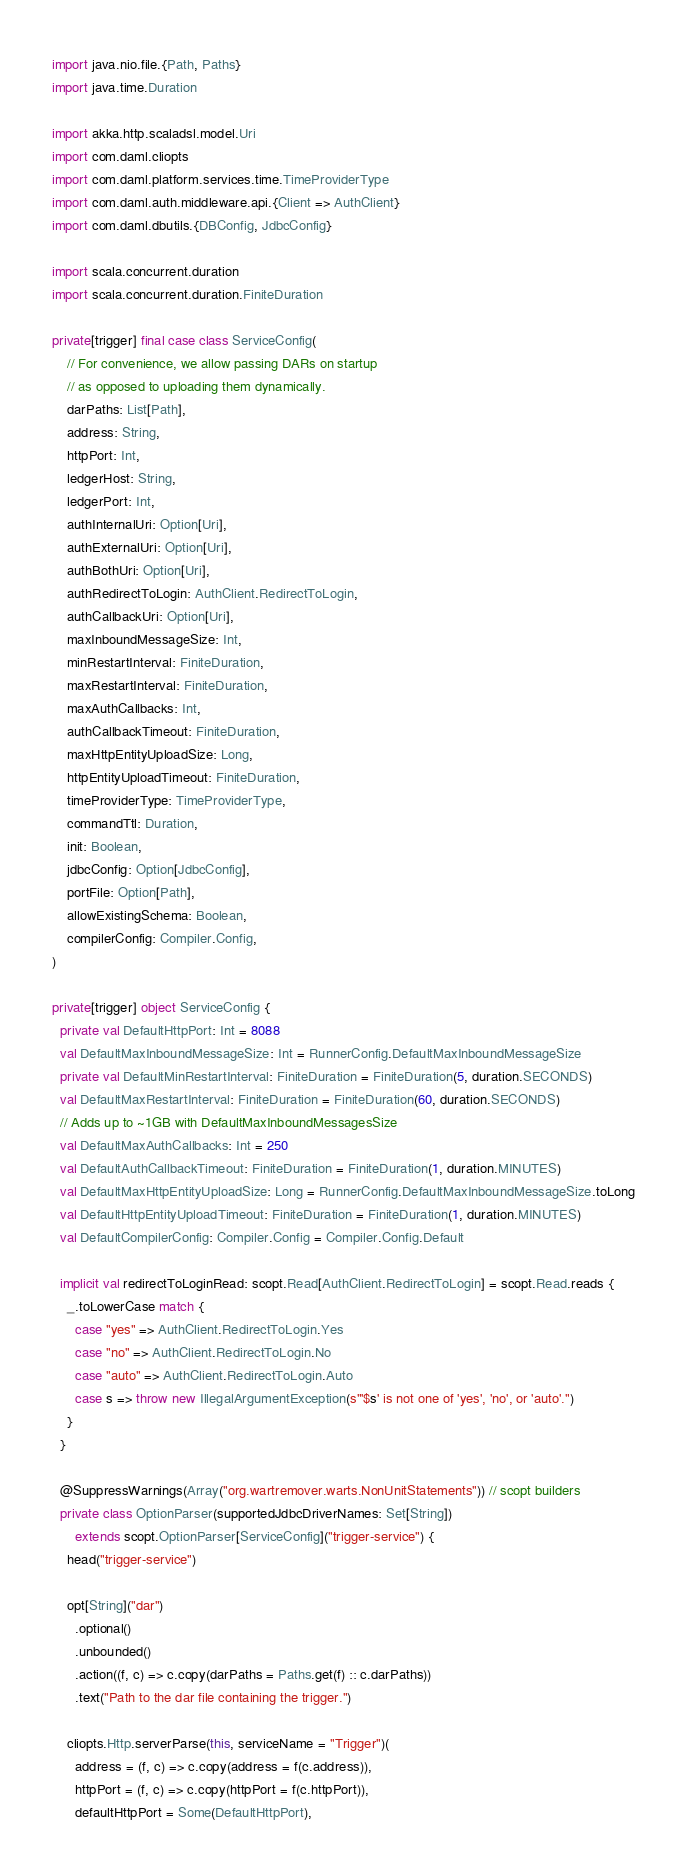Convert code to text. <code><loc_0><loc_0><loc_500><loc_500><_Scala_>
import java.nio.file.{Path, Paths}
import java.time.Duration

import akka.http.scaladsl.model.Uri
import com.daml.cliopts
import com.daml.platform.services.time.TimeProviderType
import com.daml.auth.middleware.api.{Client => AuthClient}
import com.daml.dbutils.{DBConfig, JdbcConfig}

import scala.concurrent.duration
import scala.concurrent.duration.FiniteDuration

private[trigger] final case class ServiceConfig(
    // For convenience, we allow passing DARs on startup
    // as opposed to uploading them dynamically.
    darPaths: List[Path],
    address: String,
    httpPort: Int,
    ledgerHost: String,
    ledgerPort: Int,
    authInternalUri: Option[Uri],
    authExternalUri: Option[Uri],
    authBothUri: Option[Uri],
    authRedirectToLogin: AuthClient.RedirectToLogin,
    authCallbackUri: Option[Uri],
    maxInboundMessageSize: Int,
    minRestartInterval: FiniteDuration,
    maxRestartInterval: FiniteDuration,
    maxAuthCallbacks: Int,
    authCallbackTimeout: FiniteDuration,
    maxHttpEntityUploadSize: Long,
    httpEntityUploadTimeout: FiniteDuration,
    timeProviderType: TimeProviderType,
    commandTtl: Duration,
    init: Boolean,
    jdbcConfig: Option[JdbcConfig],
    portFile: Option[Path],
    allowExistingSchema: Boolean,
    compilerConfig: Compiler.Config,
)

private[trigger] object ServiceConfig {
  private val DefaultHttpPort: Int = 8088
  val DefaultMaxInboundMessageSize: Int = RunnerConfig.DefaultMaxInboundMessageSize
  private val DefaultMinRestartInterval: FiniteDuration = FiniteDuration(5, duration.SECONDS)
  val DefaultMaxRestartInterval: FiniteDuration = FiniteDuration(60, duration.SECONDS)
  // Adds up to ~1GB with DefaultMaxInboundMessagesSize
  val DefaultMaxAuthCallbacks: Int = 250
  val DefaultAuthCallbackTimeout: FiniteDuration = FiniteDuration(1, duration.MINUTES)
  val DefaultMaxHttpEntityUploadSize: Long = RunnerConfig.DefaultMaxInboundMessageSize.toLong
  val DefaultHttpEntityUploadTimeout: FiniteDuration = FiniteDuration(1, duration.MINUTES)
  val DefaultCompilerConfig: Compiler.Config = Compiler.Config.Default

  implicit val redirectToLoginRead: scopt.Read[AuthClient.RedirectToLogin] = scopt.Read.reads {
    _.toLowerCase match {
      case "yes" => AuthClient.RedirectToLogin.Yes
      case "no" => AuthClient.RedirectToLogin.No
      case "auto" => AuthClient.RedirectToLogin.Auto
      case s => throw new IllegalArgumentException(s"'$s' is not one of 'yes', 'no', or 'auto'.")
    }
  }

  @SuppressWarnings(Array("org.wartremover.warts.NonUnitStatements")) // scopt builders
  private class OptionParser(supportedJdbcDriverNames: Set[String])
      extends scopt.OptionParser[ServiceConfig]("trigger-service") {
    head("trigger-service")

    opt[String]("dar")
      .optional()
      .unbounded()
      .action((f, c) => c.copy(darPaths = Paths.get(f) :: c.darPaths))
      .text("Path to the dar file containing the trigger.")

    cliopts.Http.serverParse(this, serviceName = "Trigger")(
      address = (f, c) => c.copy(address = f(c.address)),
      httpPort = (f, c) => c.copy(httpPort = f(c.httpPort)),
      defaultHttpPort = Some(DefaultHttpPort),</code> 